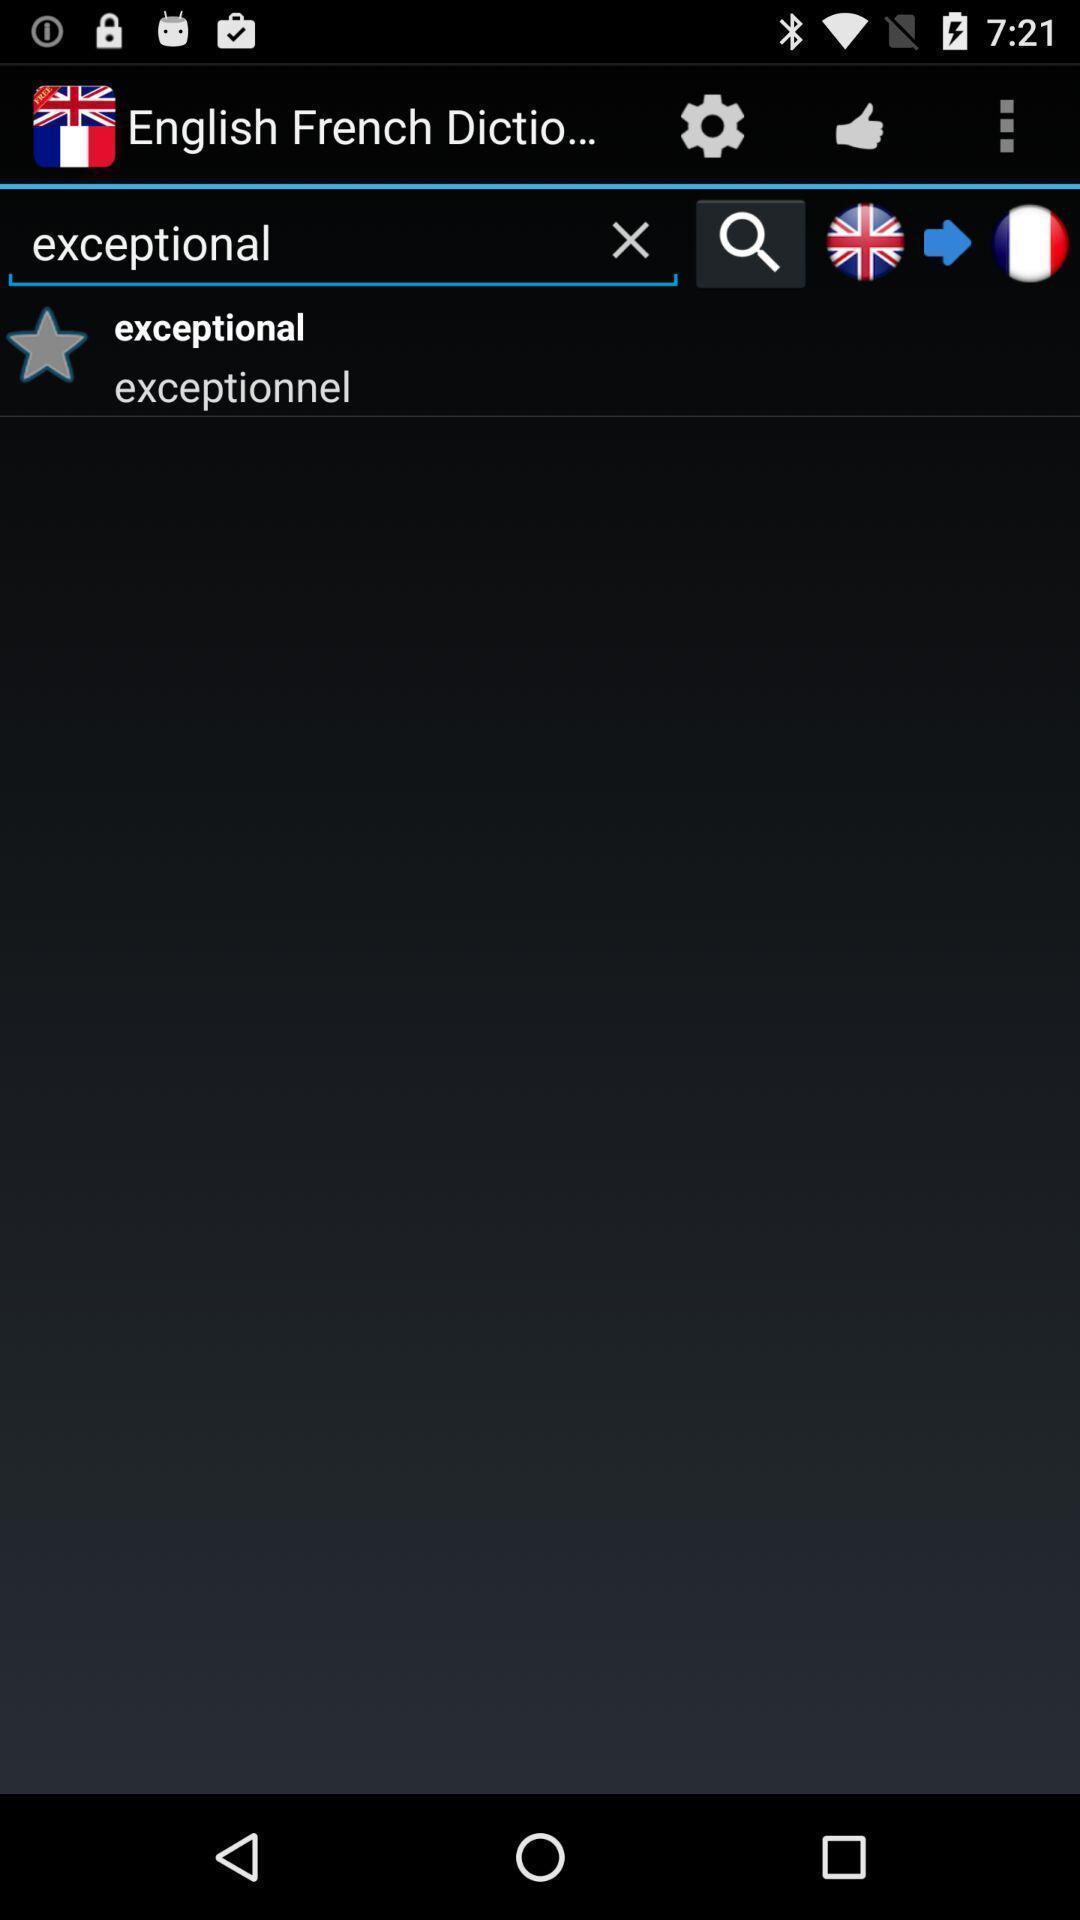What is the overall content of this screenshot? Search bar to translate from english to french. 